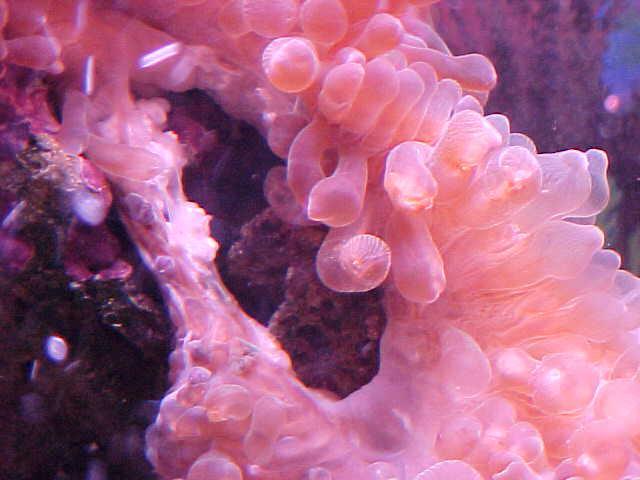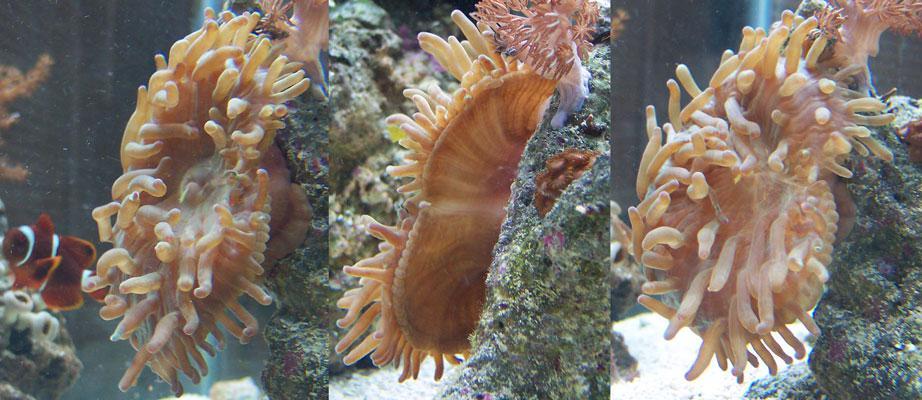The first image is the image on the left, the second image is the image on the right. Analyze the images presented: Is the assertion "In at least one image there is a single  pink corral reef with and open oval circle in the middle of the reef facing up." valid? Answer yes or no. Yes. The first image is the image on the left, the second image is the image on the right. Analyze the images presented: Is the assertion "One image shows anemone with bulbous pink tendrils, and the other image includes orange-and-white clownfish colors by anemone tendrils." valid? Answer yes or no. Yes. 